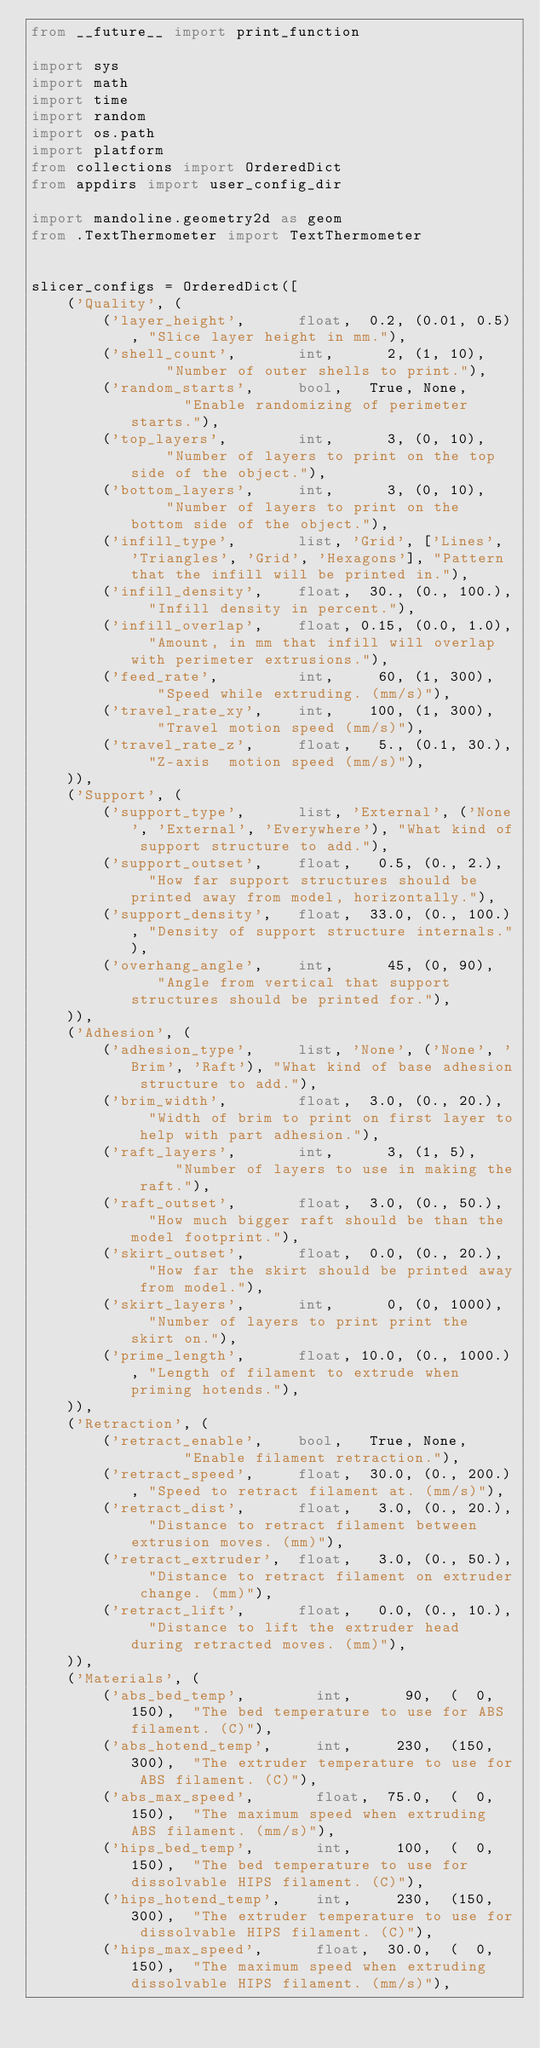<code> <loc_0><loc_0><loc_500><loc_500><_Python_>from __future__ import print_function

import sys
import math
import time
import random
import os.path
import platform
from collections import OrderedDict
from appdirs import user_config_dir

import mandoline.geometry2d as geom
from .TextThermometer import TextThermometer


slicer_configs = OrderedDict([
    ('Quality', (
        ('layer_height',      float,  0.2, (0.01, 0.5), "Slice layer height in mm."),
        ('shell_count',       int,      2, (1, 10),     "Number of outer shells to print."),
        ('random_starts',     bool,   True, None,       "Enable randomizing of perimeter starts."),
        ('top_layers',        int,      3, (0, 10),     "Number of layers to print on the top side of the object."),
        ('bottom_layers',     int,      3, (0, 10),     "Number of layers to print on the bottom side of the object."),
        ('infill_type',       list, 'Grid', ['Lines', 'Triangles', 'Grid', 'Hexagons'], "Pattern that the infill will be printed in."),
        ('infill_density',    float,  30., (0., 100.),  "Infill density in percent."),
        ('infill_overlap',    float, 0.15, (0.0, 1.0),  "Amount, in mm that infill will overlap with perimeter extrusions."),
        ('feed_rate',         int,     60, (1, 300),    "Speed while extruding. (mm/s)"),
        ('travel_rate_xy',    int,    100, (1, 300),    "Travel motion speed (mm/s)"),
        ('travel_rate_z',     float,   5., (0.1, 30.),  "Z-axis  motion speed (mm/s)"),
    )),
    ('Support', (
        ('support_type',      list, 'External', ('None', 'External', 'Everywhere'), "What kind of support structure to add."),
        ('support_outset',    float,   0.5, (0., 2.),   "How far support structures should be printed away from model, horizontally."),
        ('support_density',   float,  33.0, (0., 100.), "Density of support structure internals."),
        ('overhang_angle',    int,      45, (0, 90),    "Angle from vertical that support structures should be printed for."),
    )),
    ('Adhesion', (
        ('adhesion_type',     list, 'None', ('None', 'Brim', 'Raft'), "What kind of base adhesion structure to add."),
        ('brim_width',        float,  3.0, (0., 20.),   "Width of brim to print on first layer to help with part adhesion."),
        ('raft_layers',       int,      3, (1, 5),      "Number of layers to use in making the raft."),
        ('raft_outset',       float,  3.0, (0., 50.),   "How much bigger raft should be than the model footprint."),
        ('skirt_outset',      float,  0.0, (0., 20.),   "How far the skirt should be printed away from model."),
        ('skirt_layers',      int,      0, (0, 1000),   "Number of layers to print print the skirt on."),
        ('prime_length',      float, 10.0, (0., 1000.), "Length of filament to extrude when priming hotends."),
    )),
    ('Retraction', (
        ('retract_enable',    bool,   True, None,       "Enable filament retraction."),
        ('retract_speed',     float,  30.0, (0., 200.), "Speed to retract filament at. (mm/s)"),
        ('retract_dist',      float,   3.0, (0., 20.),  "Distance to retract filament between extrusion moves. (mm)"),
        ('retract_extruder',  float,   3.0, (0., 50.),  "Distance to retract filament on extruder change. (mm)"),
        ('retract_lift',      float,   0.0, (0., 10.),  "Distance to lift the extruder head during retracted moves. (mm)"),
    )),
    ('Materials', (
        ('abs_bed_temp',        int,      90,  (  0, 150),  "The bed temperature to use for ABS filament. (C)"),
        ('abs_hotend_temp',     int,     230,  (150, 300),  "The extruder temperature to use for ABS filament. (C)"),
        ('abs_max_speed',       float,  75.0,  (  0, 150),  "The maximum speed when extruding ABS filament. (mm/s)"),
        ('hips_bed_temp',       int,     100,  (  0, 150),  "The bed temperature to use for dissolvable HIPS filament. (C)"),
        ('hips_hotend_temp',    int,     230,  (150, 300),  "The extruder temperature to use for dissolvable HIPS filament. (C)"),
        ('hips_max_speed',      float,  30.0,  (  0, 150),  "The maximum speed when extruding dissolvable HIPS filament. (mm/s)"),</code> 